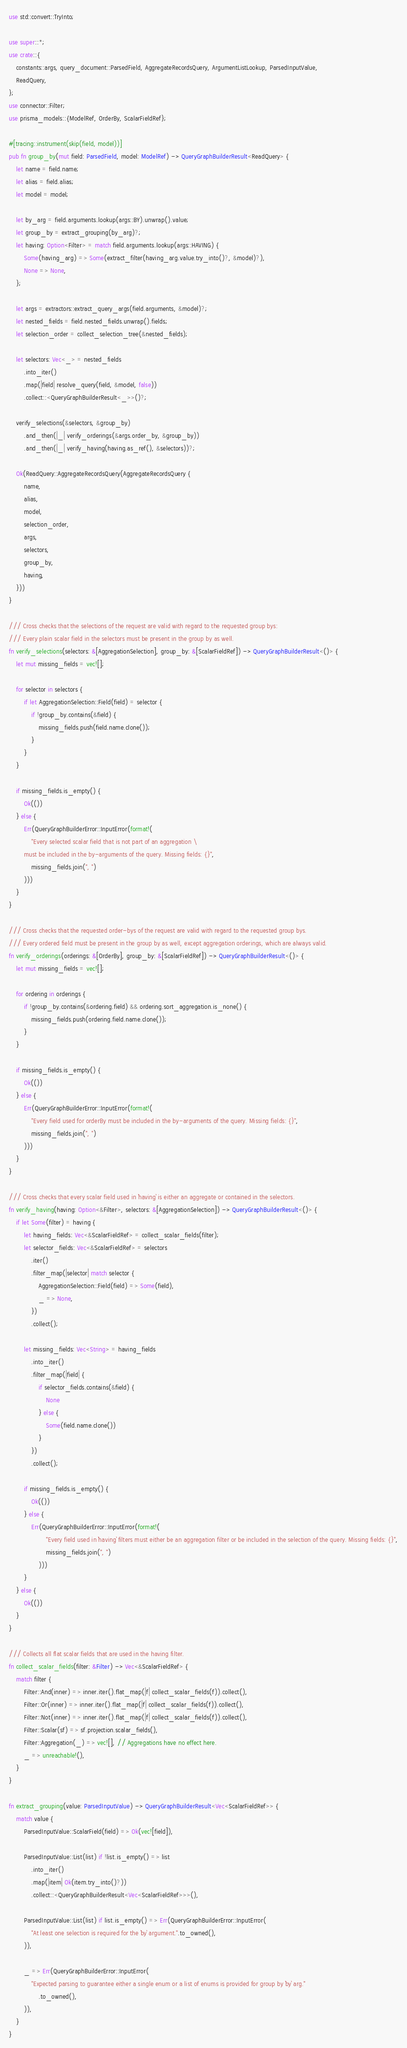<code> <loc_0><loc_0><loc_500><loc_500><_Rust_>use std::convert::TryInto;

use super::*;
use crate::{
    constants::args, query_document::ParsedField, AggregateRecordsQuery, ArgumentListLookup, ParsedInputValue,
    ReadQuery,
};
use connector::Filter;
use prisma_models::{ModelRef, OrderBy, ScalarFieldRef};

#[tracing::instrument(skip(field, model))]
pub fn group_by(mut field: ParsedField, model: ModelRef) -> QueryGraphBuilderResult<ReadQuery> {
    let name = field.name;
    let alias = field.alias;
    let model = model;

    let by_arg = field.arguments.lookup(args::BY).unwrap().value;
    let group_by = extract_grouping(by_arg)?;
    let having: Option<Filter> = match field.arguments.lookup(args::HAVING) {
        Some(having_arg) => Some(extract_filter(having_arg.value.try_into()?, &model)?),
        None => None,
    };

    let args = extractors::extract_query_args(field.arguments, &model)?;
    let nested_fields = field.nested_fields.unwrap().fields;
    let selection_order = collect_selection_tree(&nested_fields);

    let selectors: Vec<_> = nested_fields
        .into_iter()
        .map(|field| resolve_query(field, &model, false))
        .collect::<QueryGraphBuilderResult<_>>()?;

    verify_selections(&selectors, &group_by)
        .and_then(|_| verify_orderings(&args.order_by, &group_by))
        .and_then(|_| verify_having(having.as_ref(), &selectors))?;

    Ok(ReadQuery::AggregateRecordsQuery(AggregateRecordsQuery {
        name,
        alias,
        model,
        selection_order,
        args,
        selectors,
        group_by,
        having,
    }))
}

/// Cross checks that the selections of the request are valid with regard to the requested group bys:
/// Every plain scalar field in the selectors must be present in the group by as well.
fn verify_selections(selectors: &[AggregationSelection], group_by: &[ScalarFieldRef]) -> QueryGraphBuilderResult<()> {
    let mut missing_fields = vec![];

    for selector in selectors {
        if let AggregationSelection::Field(field) = selector {
            if !group_by.contains(&field) {
                missing_fields.push(field.name.clone());
            }
        }
    }

    if missing_fields.is_empty() {
        Ok(())
    } else {
        Err(QueryGraphBuilderError::InputError(format!(
            "Every selected scalar field that is not part of an aggregation \
        must be included in the by-arguments of the query. Missing fields: {}",
            missing_fields.join(", ")
        )))
    }
}

/// Cross checks that the requested order-bys of the request are valid with regard to the requested group bys.
/// Every ordered field must be present in the group by as well, except aggregation orderings, which are always valid.
fn verify_orderings(orderings: &[OrderBy], group_by: &[ScalarFieldRef]) -> QueryGraphBuilderResult<()> {
    let mut missing_fields = vec![];

    for ordering in orderings {
        if !group_by.contains(&ordering.field) && ordering.sort_aggregation.is_none() {
            missing_fields.push(ordering.field.name.clone());
        }
    }

    if missing_fields.is_empty() {
        Ok(())
    } else {
        Err(QueryGraphBuilderError::InputError(format!(
            "Every field used for orderBy must be included in the by-arguments of the query. Missing fields: {}",
            missing_fields.join(", ")
        )))
    }
}

/// Cross checks that every scalar field used in `having` is either an aggregate or contained in the selectors.
fn verify_having(having: Option<&Filter>, selectors: &[AggregationSelection]) -> QueryGraphBuilderResult<()> {
    if let Some(filter) = having {
        let having_fields: Vec<&ScalarFieldRef> = collect_scalar_fields(filter);
        let selector_fields: Vec<&ScalarFieldRef> = selectors
            .iter()
            .filter_map(|selector| match selector {
                AggregationSelection::Field(field) => Some(field),
                _ => None,
            })
            .collect();

        let missing_fields: Vec<String> = having_fields
            .into_iter()
            .filter_map(|field| {
                if selector_fields.contains(&field) {
                    None
                } else {
                    Some(field.name.clone())
                }
            })
            .collect();

        if missing_fields.is_empty() {
            Ok(())
        } else {
            Err(QueryGraphBuilderError::InputError(format!(
                    "Every field used in `having` filters must either be an aggregation filter or be included in the selection of the query. Missing fields: {}",
                    missing_fields.join(", ")
                )))
        }
    } else {
        Ok(())
    }
}

/// Collects all flat scalar fields that are used in the having filter.
fn collect_scalar_fields(filter: &Filter) -> Vec<&ScalarFieldRef> {
    match filter {
        Filter::And(inner) => inner.iter().flat_map(|f| collect_scalar_fields(f)).collect(),
        Filter::Or(inner) => inner.iter().flat_map(|f| collect_scalar_fields(f)).collect(),
        Filter::Not(inner) => inner.iter().flat_map(|f| collect_scalar_fields(f)).collect(),
        Filter::Scalar(sf) => sf.projection.scalar_fields(),
        Filter::Aggregation(_) => vec![], // Aggregations have no effect here.
        _ => unreachable!(),
    }
}

fn extract_grouping(value: ParsedInputValue) -> QueryGraphBuilderResult<Vec<ScalarFieldRef>> {
    match value {
        ParsedInputValue::ScalarField(field) => Ok(vec![field]),

        ParsedInputValue::List(list) if !list.is_empty() => list
            .into_iter()
            .map(|item| Ok(item.try_into()?))
            .collect::<QueryGraphBuilderResult<Vec<ScalarFieldRef>>>(),

        ParsedInputValue::List(list) if list.is_empty() => Err(QueryGraphBuilderError::InputError(
            "At least one selection is required for the `by` argument.".to_owned(),
        )),

        _ => Err(QueryGraphBuilderError::InputError(
            "Expected parsing to guarantee either a single enum or a list of enums is provided for group by `by` arg."
                .to_owned(),
        )),
    }
}
</code> 